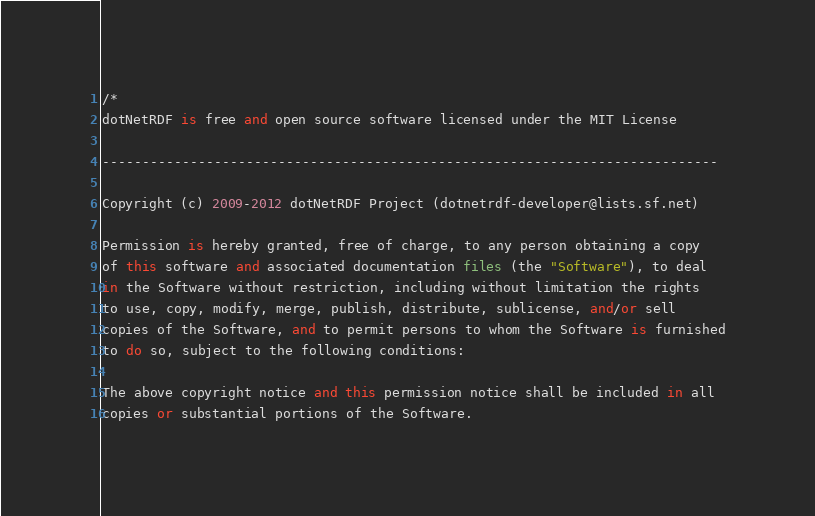Convert code to text. <code><loc_0><loc_0><loc_500><loc_500><_C#_>/*
dotNetRDF is free and open source software licensed under the MIT License

-----------------------------------------------------------------------------

Copyright (c) 2009-2012 dotNetRDF Project (dotnetrdf-developer@lists.sf.net)

Permission is hereby granted, free of charge, to any person obtaining a copy
of this software and associated documentation files (the "Software"), to deal
in the Software without restriction, including without limitation the rights
to use, copy, modify, merge, publish, distribute, sublicense, and/or sell
copies of the Software, and to permit persons to whom the Software is furnished
to do so, subject to the following conditions:

The above copyright notice and this permission notice shall be included in all
copies or substantial portions of the Software.
</code> 